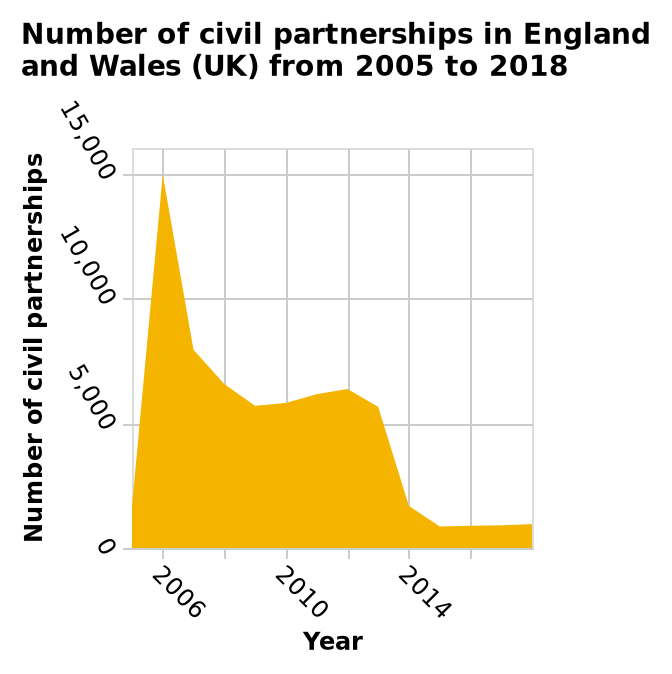<image>
Is there a correlation between the number of civil partnerships in England and Wales and the years from 2005 to 2018?  Yes, there is a correlation between the number of civil partnerships and the years from 2005 to 2018. What is the timeframe covered by the area plot? The area plot covers the period from 2005 to 2018. Can we conclude that fewer civil partnerships were formed in England and Wales as the years progressed from 2005 to 2018?  Yes, we can conclude that fewer civil partnerships were formed in England and Wales as the years progressed from 2005 to 2018. 